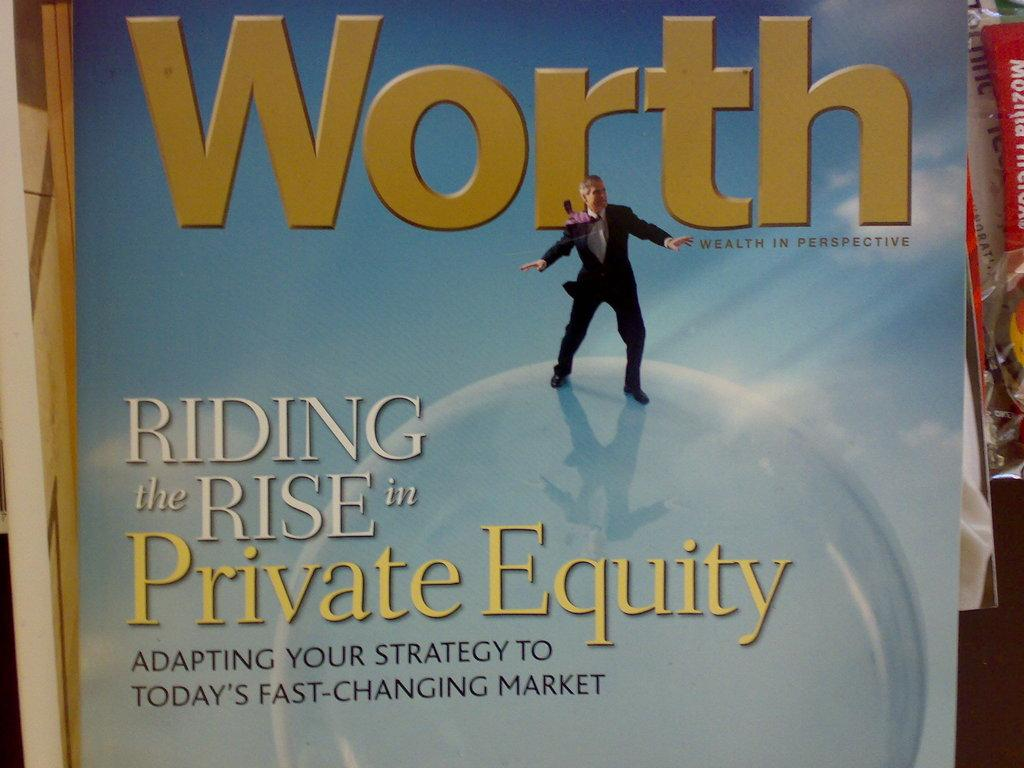<image>
Present a compact description of the photo's key features. Poster that shows a man on top of a globe and the word "Worth" above him. 